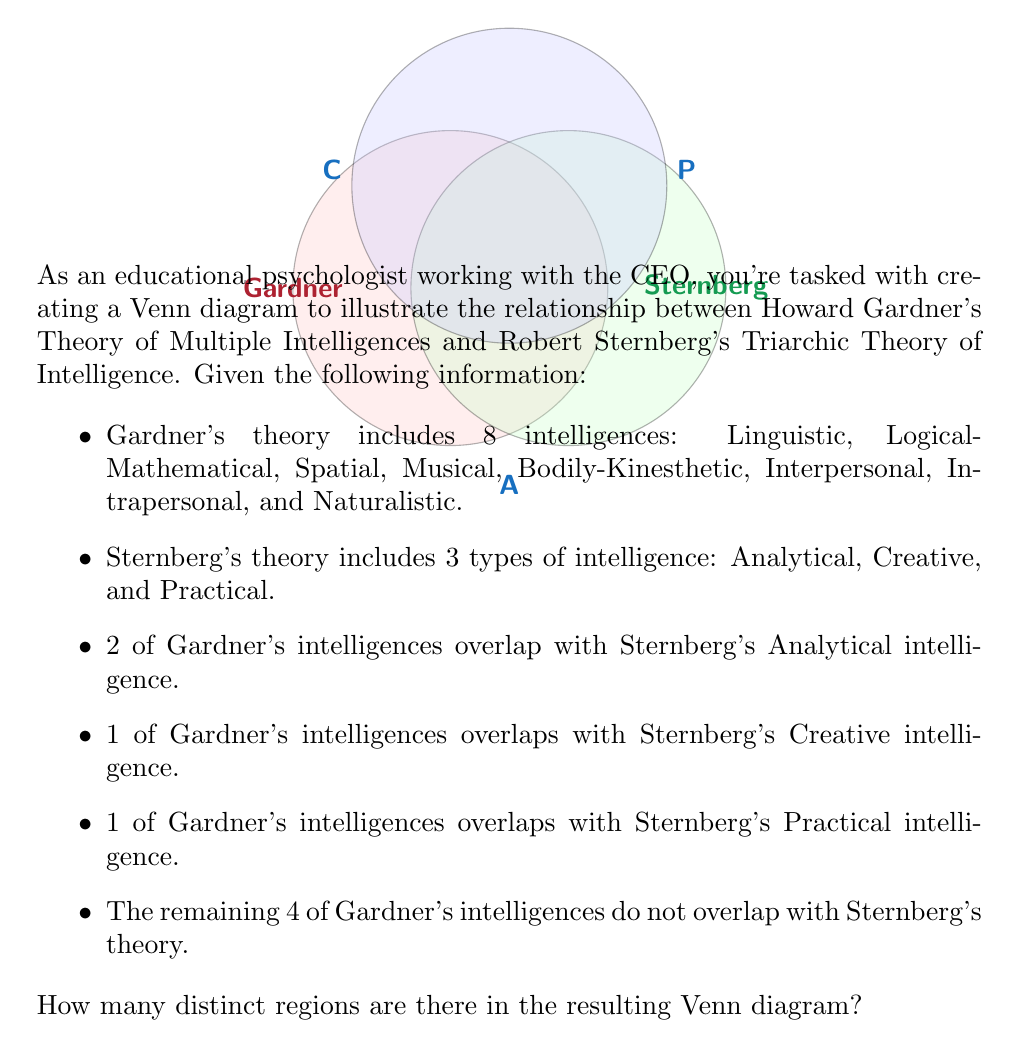Could you help me with this problem? To solve this problem, let's break it down step-by-step:

1) First, we need to understand what the Venn diagram will look like. We'll have two main sets:
   - Gardner's set (8 intelligences)
   - Sternberg's set (3 types of intelligence)

2) Sternberg's set will be divided into three subsets: Analytical (A), Creative (C), and Practical (P).

3) Now, let's count the regions:
   a) Gardner's exclusive region: 4 intelligences
   b) Overlap with Analytical: 2 intelligences
   c) Overlap with Creative: 1 intelligence
   d) Overlap with Practical: 1 intelligence
   e) Sternberg's exclusive Analytical region: 1 region
   f) Sternberg's exclusive Creative region: 1 region
   g) Sternberg's exclusive Practical region: 1 region

4) Additionally, we need to consider the regions created by the intersections of Sternberg's subsets:
   h) Intersection of A and C
   i) Intersection of A and P
   j) Intersection of C and P
   k) Intersection of A, C, and P

5) Finally, we need to include the region outside all sets.

6) Counting all these regions:
   $$4 + 2 + 1 + 1 + 1 + 1 + 1 + 1 + 1 + 1 + 1 + 1 = 16$$

Therefore, there are 16 distinct regions in the Venn diagram.
Answer: 16 regions 